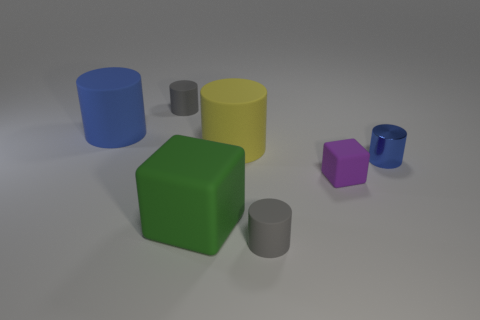Is the material of the yellow thing the same as the small blue cylinder?
Keep it short and to the point. No. How many other things are there of the same shape as the big green matte thing?
Keep it short and to the point. 1. What shape is the matte object that is both on the right side of the big blue cylinder and to the left of the big green object?
Offer a very short reply. Cylinder. There is a rubber cylinder left of the small gray object that is behind the big green rubber cube on the left side of the tiny metallic thing; what is its color?
Provide a short and direct response. Blue. Are there more tiny gray cylinders that are behind the large green rubber cube than metal objects to the left of the large yellow matte object?
Provide a short and direct response. Yes. How many other objects are there of the same size as the green matte thing?
Keep it short and to the point. 2. There is a matte cylinder that is the same color as the tiny metallic cylinder; what is its size?
Provide a succinct answer. Large. The blue thing right of the gray matte thing that is behind the big blue cylinder is made of what material?
Your answer should be compact. Metal. There is a small purple thing; are there any green objects on the right side of it?
Provide a short and direct response. No. Are there more matte blocks to the left of the purple cube than small brown spheres?
Your response must be concise. Yes. 